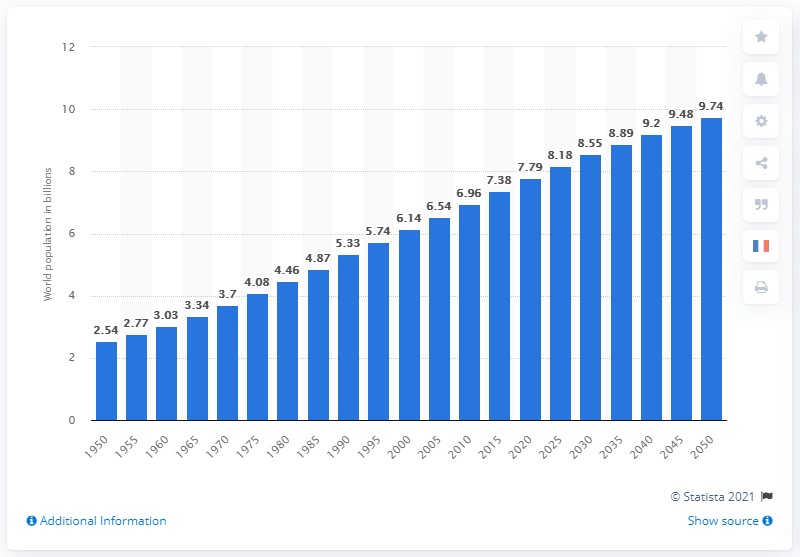Mention a couple of crucial points in this snapshot. In 2015, the population of the world was approximately 7.38 billion people. 